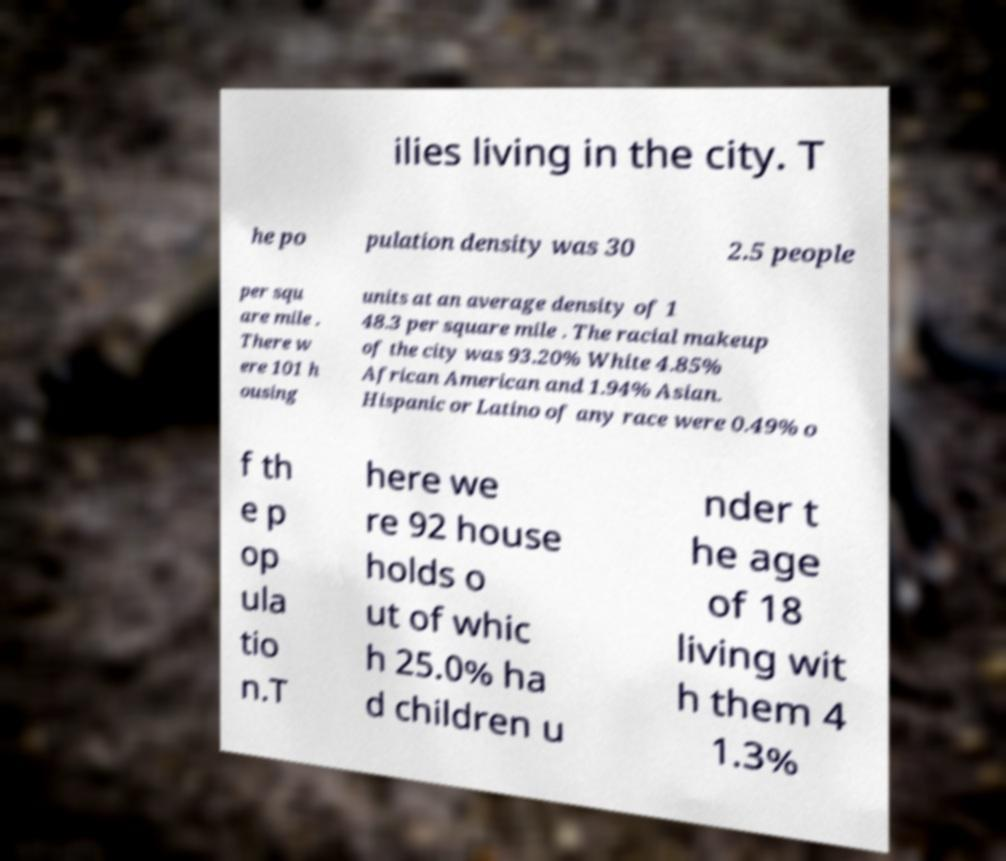Can you accurately transcribe the text from the provided image for me? ilies living in the city. T he po pulation density was 30 2.5 people per squ are mile . There w ere 101 h ousing units at an average density of 1 48.3 per square mile . The racial makeup of the city was 93.20% White 4.85% African American and 1.94% Asian. Hispanic or Latino of any race were 0.49% o f th e p op ula tio n.T here we re 92 house holds o ut of whic h 25.0% ha d children u nder t he age of 18 living wit h them 4 1.3% 